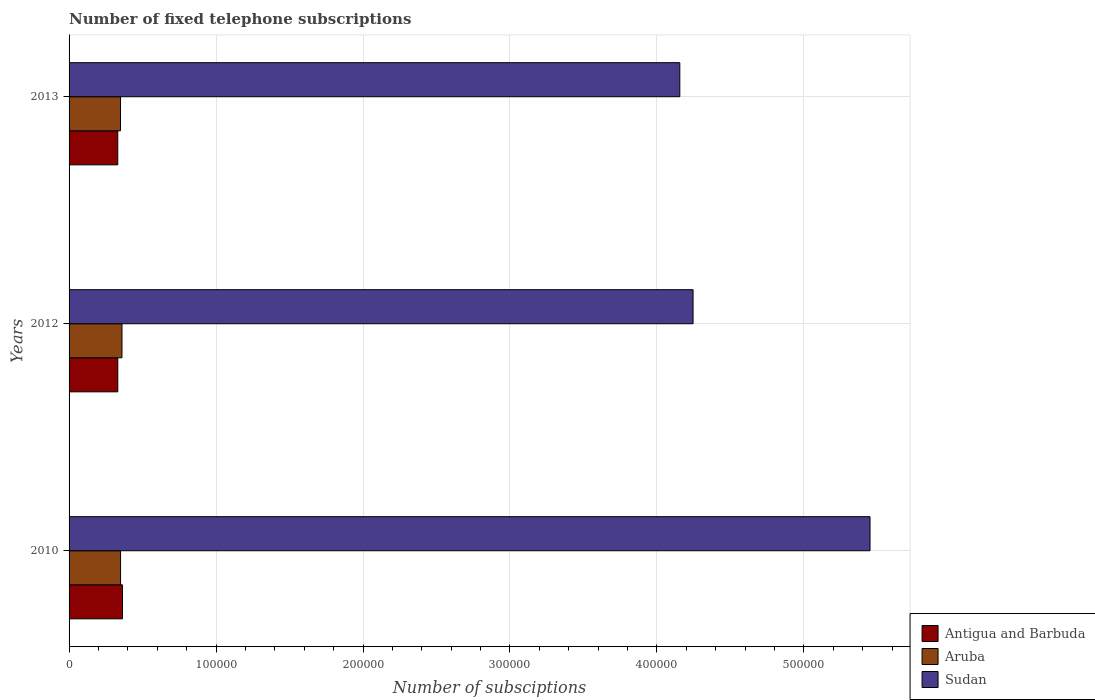How many different coloured bars are there?
Make the answer very short. 3. How many groups of bars are there?
Offer a very short reply. 3. Are the number of bars per tick equal to the number of legend labels?
Give a very brief answer. Yes. How many bars are there on the 2nd tick from the top?
Keep it short and to the point. 3. What is the label of the 1st group of bars from the top?
Offer a very short reply. 2013. What is the number of fixed telephone subscriptions in Aruba in 2010?
Offer a terse response. 3.50e+04. Across all years, what is the maximum number of fixed telephone subscriptions in Antigua and Barbuda?
Your answer should be very brief. 3.63e+04. Across all years, what is the minimum number of fixed telephone subscriptions in Aruba?
Your answer should be very brief. 3.50e+04. In which year was the number of fixed telephone subscriptions in Antigua and Barbuda maximum?
Give a very brief answer. 2010. In which year was the number of fixed telephone subscriptions in Sudan minimum?
Your answer should be compact. 2013. What is the total number of fixed telephone subscriptions in Antigua and Barbuda in the graph?
Make the answer very short. 1.03e+05. What is the difference between the number of fixed telephone subscriptions in Aruba in 2010 and that in 2013?
Offer a terse response. 40. What is the difference between the number of fixed telephone subscriptions in Aruba in 2010 and the number of fixed telephone subscriptions in Sudan in 2012?
Offer a very short reply. -3.90e+05. What is the average number of fixed telephone subscriptions in Sudan per year?
Make the answer very short. 4.62e+05. In the year 2013, what is the difference between the number of fixed telephone subscriptions in Antigua and Barbuda and number of fixed telephone subscriptions in Sudan?
Provide a short and direct response. -3.82e+05. In how many years, is the number of fixed telephone subscriptions in Aruba greater than 280000 ?
Give a very brief answer. 0. What is the ratio of the number of fixed telephone subscriptions in Sudan in 2010 to that in 2012?
Provide a succinct answer. 1.28. Is the difference between the number of fixed telephone subscriptions in Antigua and Barbuda in 2010 and 2012 greater than the difference between the number of fixed telephone subscriptions in Sudan in 2010 and 2012?
Your response must be concise. No. What is the difference between the highest and the second highest number of fixed telephone subscriptions in Antigua and Barbuda?
Your response must be concise. 3163. What is the difference between the highest and the lowest number of fixed telephone subscriptions in Sudan?
Your answer should be very brief. 1.29e+05. In how many years, is the number of fixed telephone subscriptions in Aruba greater than the average number of fixed telephone subscriptions in Aruba taken over all years?
Offer a terse response. 1. What does the 3rd bar from the top in 2010 represents?
Your answer should be compact. Antigua and Barbuda. What does the 1st bar from the bottom in 2012 represents?
Your answer should be compact. Antigua and Barbuda. Is it the case that in every year, the sum of the number of fixed telephone subscriptions in Sudan and number of fixed telephone subscriptions in Aruba is greater than the number of fixed telephone subscriptions in Antigua and Barbuda?
Provide a short and direct response. Yes. Are all the bars in the graph horizontal?
Offer a terse response. Yes. Are the values on the major ticks of X-axis written in scientific E-notation?
Your answer should be compact. No. Does the graph contain any zero values?
Provide a short and direct response. No. Does the graph contain grids?
Offer a very short reply. Yes. Where does the legend appear in the graph?
Keep it short and to the point. Bottom right. How many legend labels are there?
Keep it short and to the point. 3. What is the title of the graph?
Keep it short and to the point. Number of fixed telephone subscriptions. What is the label or title of the X-axis?
Keep it short and to the point. Number of subsciptions. What is the label or title of the Y-axis?
Your answer should be compact. Years. What is the Number of subsciptions of Antigua and Barbuda in 2010?
Offer a terse response. 3.63e+04. What is the Number of subsciptions in Aruba in 2010?
Ensure brevity in your answer.  3.50e+04. What is the Number of subsciptions in Sudan in 2010?
Offer a very short reply. 5.45e+05. What is the Number of subsciptions of Antigua and Barbuda in 2012?
Your answer should be very brief. 3.32e+04. What is the Number of subsciptions of Aruba in 2012?
Provide a short and direct response. 3.60e+04. What is the Number of subsciptions in Sudan in 2012?
Keep it short and to the point. 4.25e+05. What is the Number of subsciptions of Antigua and Barbuda in 2013?
Make the answer very short. 3.31e+04. What is the Number of subsciptions in Aruba in 2013?
Ensure brevity in your answer.  3.50e+04. What is the Number of subsciptions of Sudan in 2013?
Offer a terse response. 4.16e+05. Across all years, what is the maximum Number of subsciptions of Antigua and Barbuda?
Offer a terse response. 3.63e+04. Across all years, what is the maximum Number of subsciptions in Aruba?
Your answer should be compact. 3.60e+04. Across all years, what is the maximum Number of subsciptions in Sudan?
Offer a terse response. 5.45e+05. Across all years, what is the minimum Number of subsciptions of Antigua and Barbuda?
Provide a short and direct response. 3.31e+04. Across all years, what is the minimum Number of subsciptions in Aruba?
Give a very brief answer. 3.50e+04. Across all years, what is the minimum Number of subsciptions of Sudan?
Offer a very short reply. 4.16e+05. What is the total Number of subsciptions in Antigua and Barbuda in the graph?
Your answer should be very brief. 1.03e+05. What is the total Number of subsciptions in Aruba in the graph?
Your answer should be very brief. 1.06e+05. What is the total Number of subsciptions in Sudan in the graph?
Keep it short and to the point. 1.39e+06. What is the difference between the Number of subsciptions of Antigua and Barbuda in 2010 and that in 2012?
Make the answer very short. 3163. What is the difference between the Number of subsciptions of Aruba in 2010 and that in 2012?
Ensure brevity in your answer.  -960. What is the difference between the Number of subsciptions in Sudan in 2010 and that in 2012?
Ensure brevity in your answer.  1.20e+05. What is the difference between the Number of subsciptions in Antigua and Barbuda in 2010 and that in 2013?
Provide a succinct answer. 3189. What is the difference between the Number of subsciptions in Aruba in 2010 and that in 2013?
Your answer should be compact. 40. What is the difference between the Number of subsciptions in Sudan in 2010 and that in 2013?
Keep it short and to the point. 1.29e+05. What is the difference between the Number of subsciptions in Antigua and Barbuda in 2012 and that in 2013?
Your answer should be very brief. 26. What is the difference between the Number of subsciptions of Aruba in 2012 and that in 2013?
Give a very brief answer. 1000. What is the difference between the Number of subsciptions in Sudan in 2012 and that in 2013?
Give a very brief answer. 9015. What is the difference between the Number of subsciptions of Antigua and Barbuda in 2010 and the Number of subsciptions of Aruba in 2012?
Provide a short and direct response. 322. What is the difference between the Number of subsciptions in Antigua and Barbuda in 2010 and the Number of subsciptions in Sudan in 2012?
Make the answer very short. -3.88e+05. What is the difference between the Number of subsciptions in Aruba in 2010 and the Number of subsciptions in Sudan in 2012?
Your response must be concise. -3.90e+05. What is the difference between the Number of subsciptions of Antigua and Barbuda in 2010 and the Number of subsciptions of Aruba in 2013?
Give a very brief answer. 1322. What is the difference between the Number of subsciptions in Antigua and Barbuda in 2010 and the Number of subsciptions in Sudan in 2013?
Give a very brief answer. -3.79e+05. What is the difference between the Number of subsciptions of Aruba in 2010 and the Number of subsciptions of Sudan in 2013?
Your answer should be very brief. -3.81e+05. What is the difference between the Number of subsciptions in Antigua and Barbuda in 2012 and the Number of subsciptions in Aruba in 2013?
Your response must be concise. -1841. What is the difference between the Number of subsciptions of Antigua and Barbuda in 2012 and the Number of subsciptions of Sudan in 2013?
Offer a very short reply. -3.82e+05. What is the difference between the Number of subsciptions in Aruba in 2012 and the Number of subsciptions in Sudan in 2013?
Your answer should be very brief. -3.80e+05. What is the average Number of subsciptions of Antigua and Barbuda per year?
Your response must be concise. 3.42e+04. What is the average Number of subsciptions of Aruba per year?
Your response must be concise. 3.53e+04. What is the average Number of subsciptions of Sudan per year?
Offer a very short reply. 4.62e+05. In the year 2010, what is the difference between the Number of subsciptions of Antigua and Barbuda and Number of subsciptions of Aruba?
Offer a terse response. 1282. In the year 2010, what is the difference between the Number of subsciptions of Antigua and Barbuda and Number of subsciptions of Sudan?
Keep it short and to the point. -5.09e+05. In the year 2010, what is the difference between the Number of subsciptions in Aruba and Number of subsciptions in Sudan?
Your answer should be compact. -5.10e+05. In the year 2012, what is the difference between the Number of subsciptions in Antigua and Barbuda and Number of subsciptions in Aruba?
Your answer should be very brief. -2841. In the year 2012, what is the difference between the Number of subsciptions in Antigua and Barbuda and Number of subsciptions in Sudan?
Make the answer very short. -3.91e+05. In the year 2012, what is the difference between the Number of subsciptions of Aruba and Number of subsciptions of Sudan?
Ensure brevity in your answer.  -3.89e+05. In the year 2013, what is the difference between the Number of subsciptions in Antigua and Barbuda and Number of subsciptions in Aruba?
Keep it short and to the point. -1867. In the year 2013, what is the difference between the Number of subsciptions in Antigua and Barbuda and Number of subsciptions in Sudan?
Offer a very short reply. -3.82e+05. In the year 2013, what is the difference between the Number of subsciptions in Aruba and Number of subsciptions in Sudan?
Provide a succinct answer. -3.81e+05. What is the ratio of the Number of subsciptions in Antigua and Barbuda in 2010 to that in 2012?
Make the answer very short. 1.1. What is the ratio of the Number of subsciptions in Aruba in 2010 to that in 2012?
Give a very brief answer. 0.97. What is the ratio of the Number of subsciptions in Sudan in 2010 to that in 2012?
Keep it short and to the point. 1.28. What is the ratio of the Number of subsciptions in Antigua and Barbuda in 2010 to that in 2013?
Give a very brief answer. 1.1. What is the ratio of the Number of subsciptions of Sudan in 2010 to that in 2013?
Provide a succinct answer. 1.31. What is the ratio of the Number of subsciptions in Aruba in 2012 to that in 2013?
Offer a terse response. 1.03. What is the ratio of the Number of subsciptions of Sudan in 2012 to that in 2013?
Make the answer very short. 1.02. What is the difference between the highest and the second highest Number of subsciptions of Antigua and Barbuda?
Keep it short and to the point. 3163. What is the difference between the highest and the second highest Number of subsciptions of Aruba?
Offer a very short reply. 960. What is the difference between the highest and the second highest Number of subsciptions of Sudan?
Make the answer very short. 1.20e+05. What is the difference between the highest and the lowest Number of subsciptions of Antigua and Barbuda?
Offer a terse response. 3189. What is the difference between the highest and the lowest Number of subsciptions in Sudan?
Your answer should be very brief. 1.29e+05. 